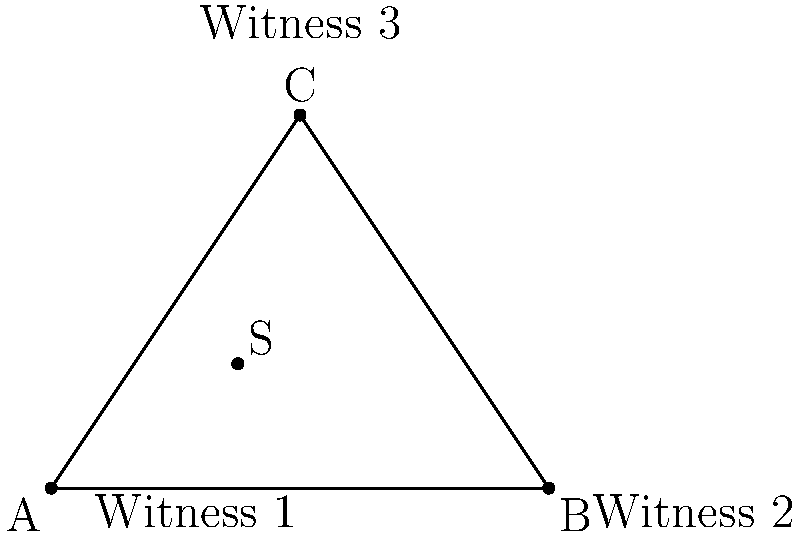Three witnesses have reported sightings of a suspect in a local park. Their positions form a triangle with coordinates A(0,0), B(8,0), and C(4,6). Based on their reports, you've determined that the suspect's location (S) is 3 units east and 2 units north of Witness 1's position. What is the distance between the suspect and Witness 3 (point C)? To find the distance between the suspect (S) and Witness 3 (C), we need to follow these steps:

1. Determine the coordinates of S:
   S is 3 units east and 2 units north of A(0,0), so S(3,2)

2. Calculate the distance using the distance formula:
   $$d = \sqrt{(x_2-x_1)^2 + (y_2-y_1)^2}$$

   Where (x₁,y₁) is S(3,2) and (x₂,y₂) is C(4,6)

3. Plug in the values:
   $$d = \sqrt{(4-3)^2 + (6-2)^2}$$

4. Simplify:
   $$d = \sqrt{1^2 + 4^2}$$
   $$d = \sqrt{1 + 16}$$
   $$d = \sqrt{17}$$

5. The distance between S and C is $\sqrt{17}$ units.
Answer: $\sqrt{17}$ units 